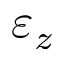<formula> <loc_0><loc_0><loc_500><loc_500>\varepsilon _ { z }</formula> 